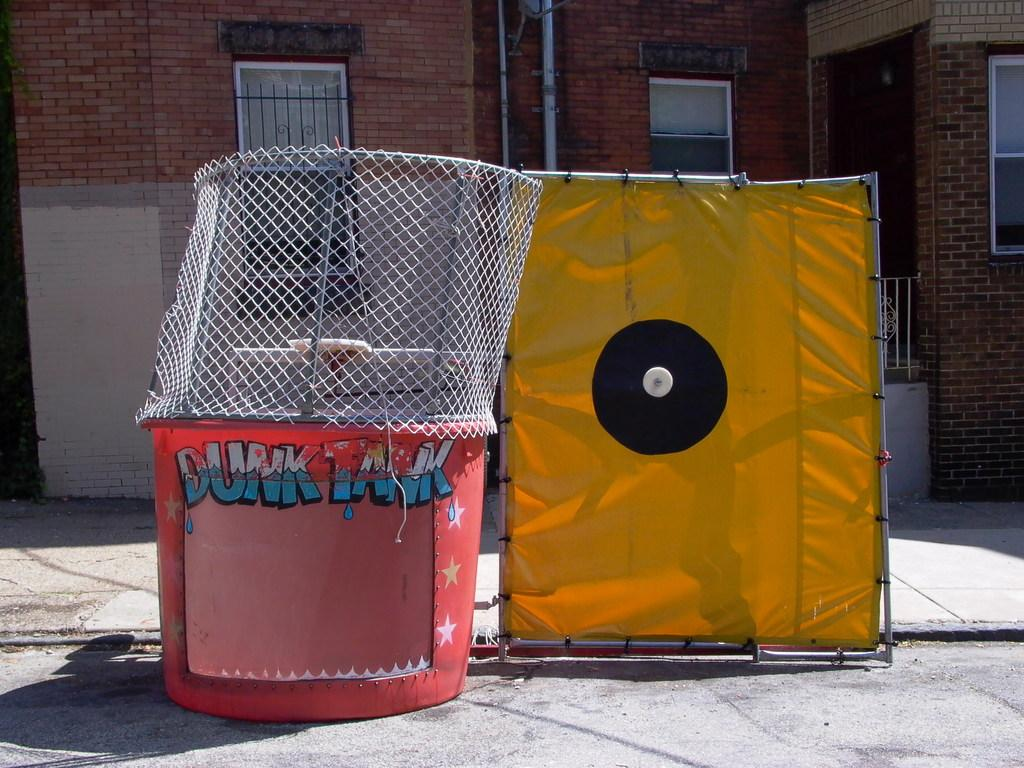<image>
Provide a brief description of the given image. A target is next to a structure labeled Dunk Tank. 